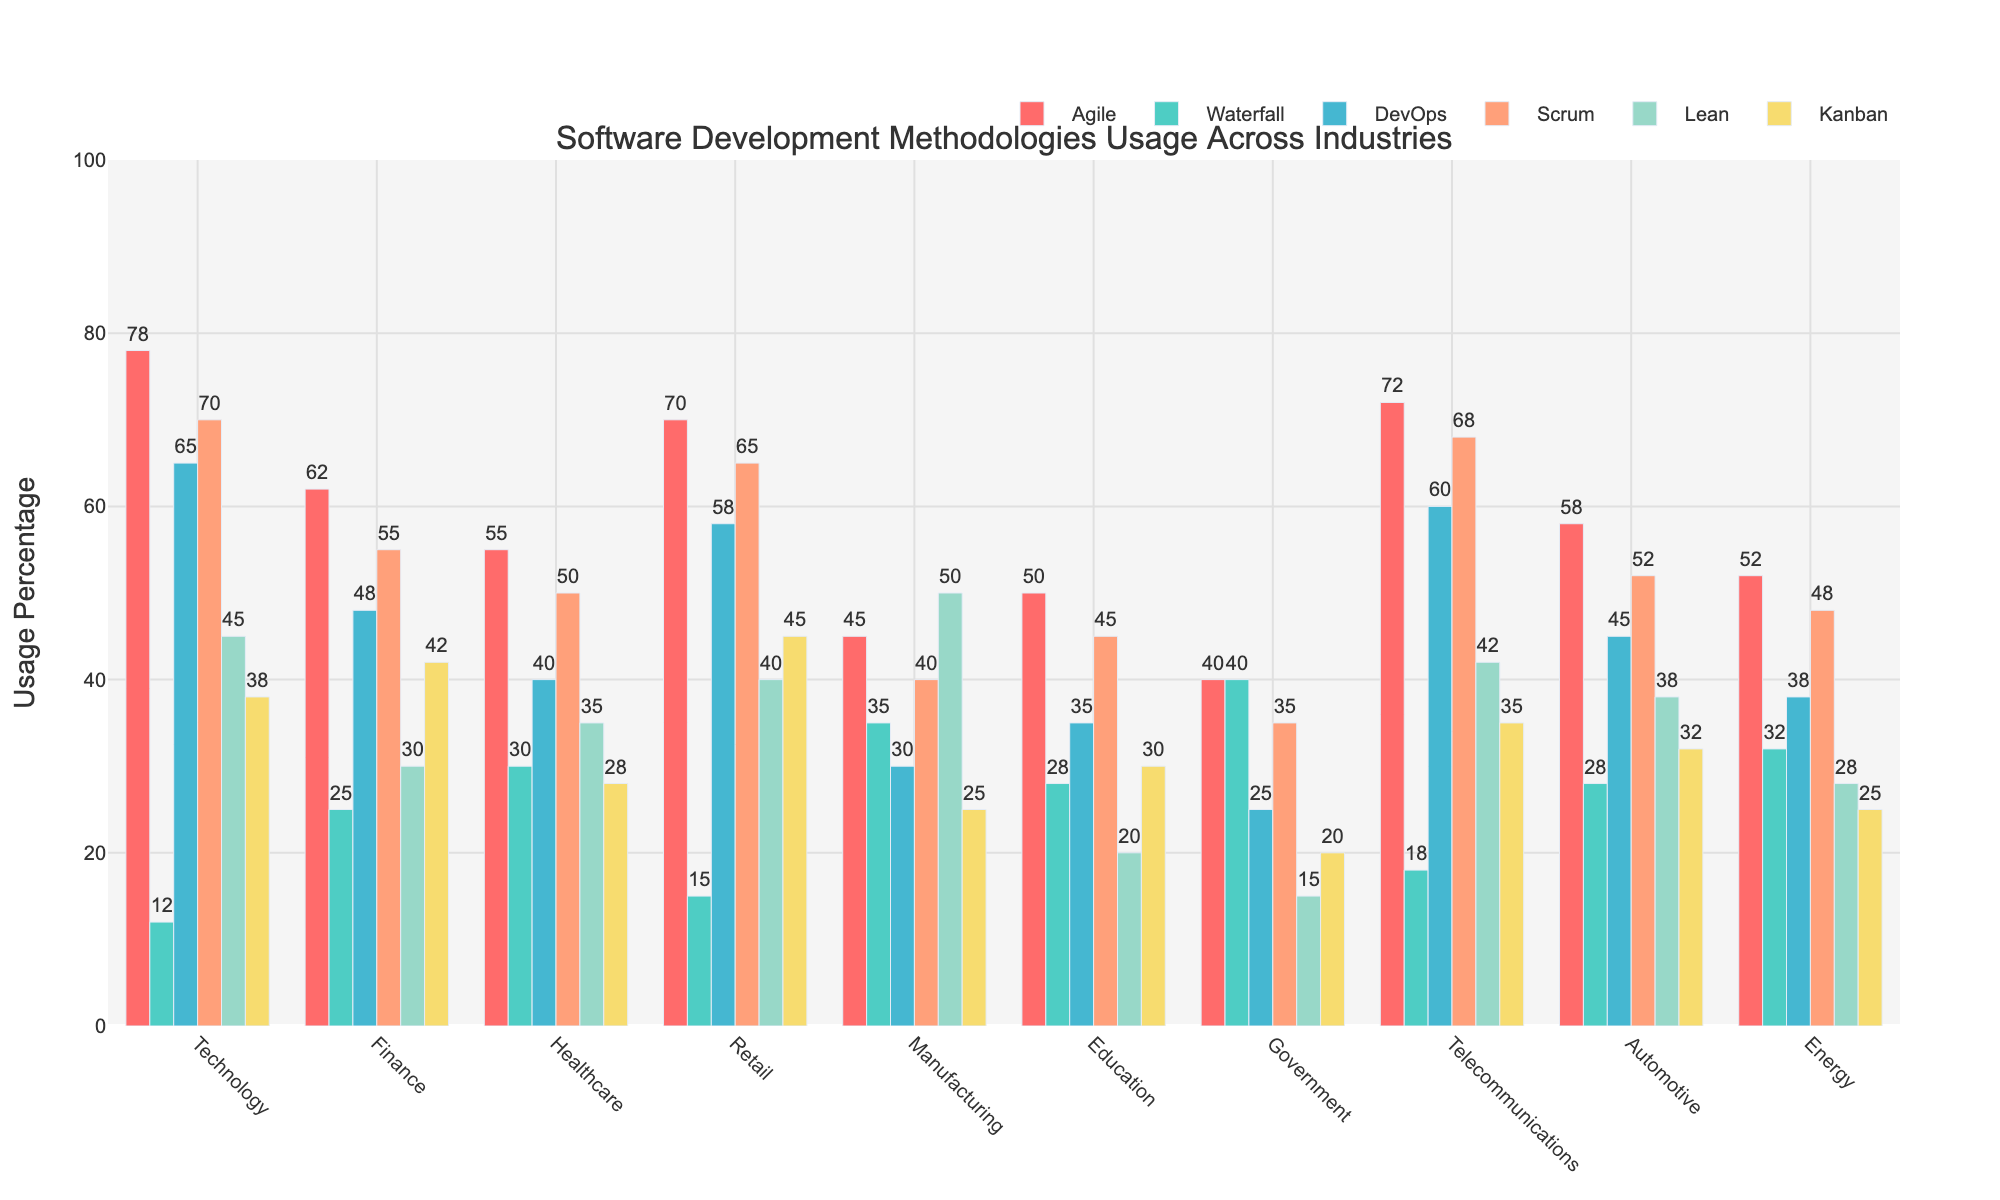Which industry has the highest usage of Agile methodology? Look at the bar heights for Agile methodology across all industries. The highest bar represents the highest usage.
Answer: Technology Which industry has the least preference for Lean methodology? Observe the bar heights for Lean methodology across all industries. The smallest bar will indicate the least preference.
Answer: Government Between Healthcare and Retail industries, which one has a higher usage of DevOps methodology? Compare the bar heights for DevOps methodology between Healthcare and Retail industries. The taller bar shows the higher usage.
Answer: Retail What is the sum of Waterfall methodology usage in Finance and Government industries? Add the percentage values for Waterfall methodology in Finance (25) and Government (40). The sum is 25 + 40.
Answer: 65 Which industry uses Scrum methodology more, Telecommunications or Manufacturing? Compare the bar heights for Scrum methodology between Telecommunications and Manufacturing. The taller bar shows the higher usage.
Answer: Telecommunications What’s the average usage percentage for Kanban methodology across all industries? Sum the Kanban percentages for all industries (38+42+28+45+25+30+20+35+32+25) and divide by the number of industries (10). The average is (38+42+28+45+25+30+20+35+32+25)/10.
Answer: 32 In which two industries is Waterfall methodology usage equal? Identify industry pairs with equal Waterfall bar heights. Waterfall usage is 28 in both Healthcare and Automotive industries.
Answer: Healthcare and Automotive Which methodology is used the least in the Automotive industry? Check the bar heights for all methodologies in the Automotive industry. The smallest bar signifies the least usage.
Answer: DevOps What is the difference in Agile methodology usage between Technology and Government industries? Subtract Government's Agile usage (40) from Technology's Agile usage (78). The difference is 78 - 40.
Answer: 38 Which industry has a higher combined usage percentage of Agile and Scrum methodologies, Energy or Education? Calculate the sum of Agile and Scrum for both Energy (52+48) and Education (50+45). Compare sums: Energy (100) and Education (95).
Answer: Energy 